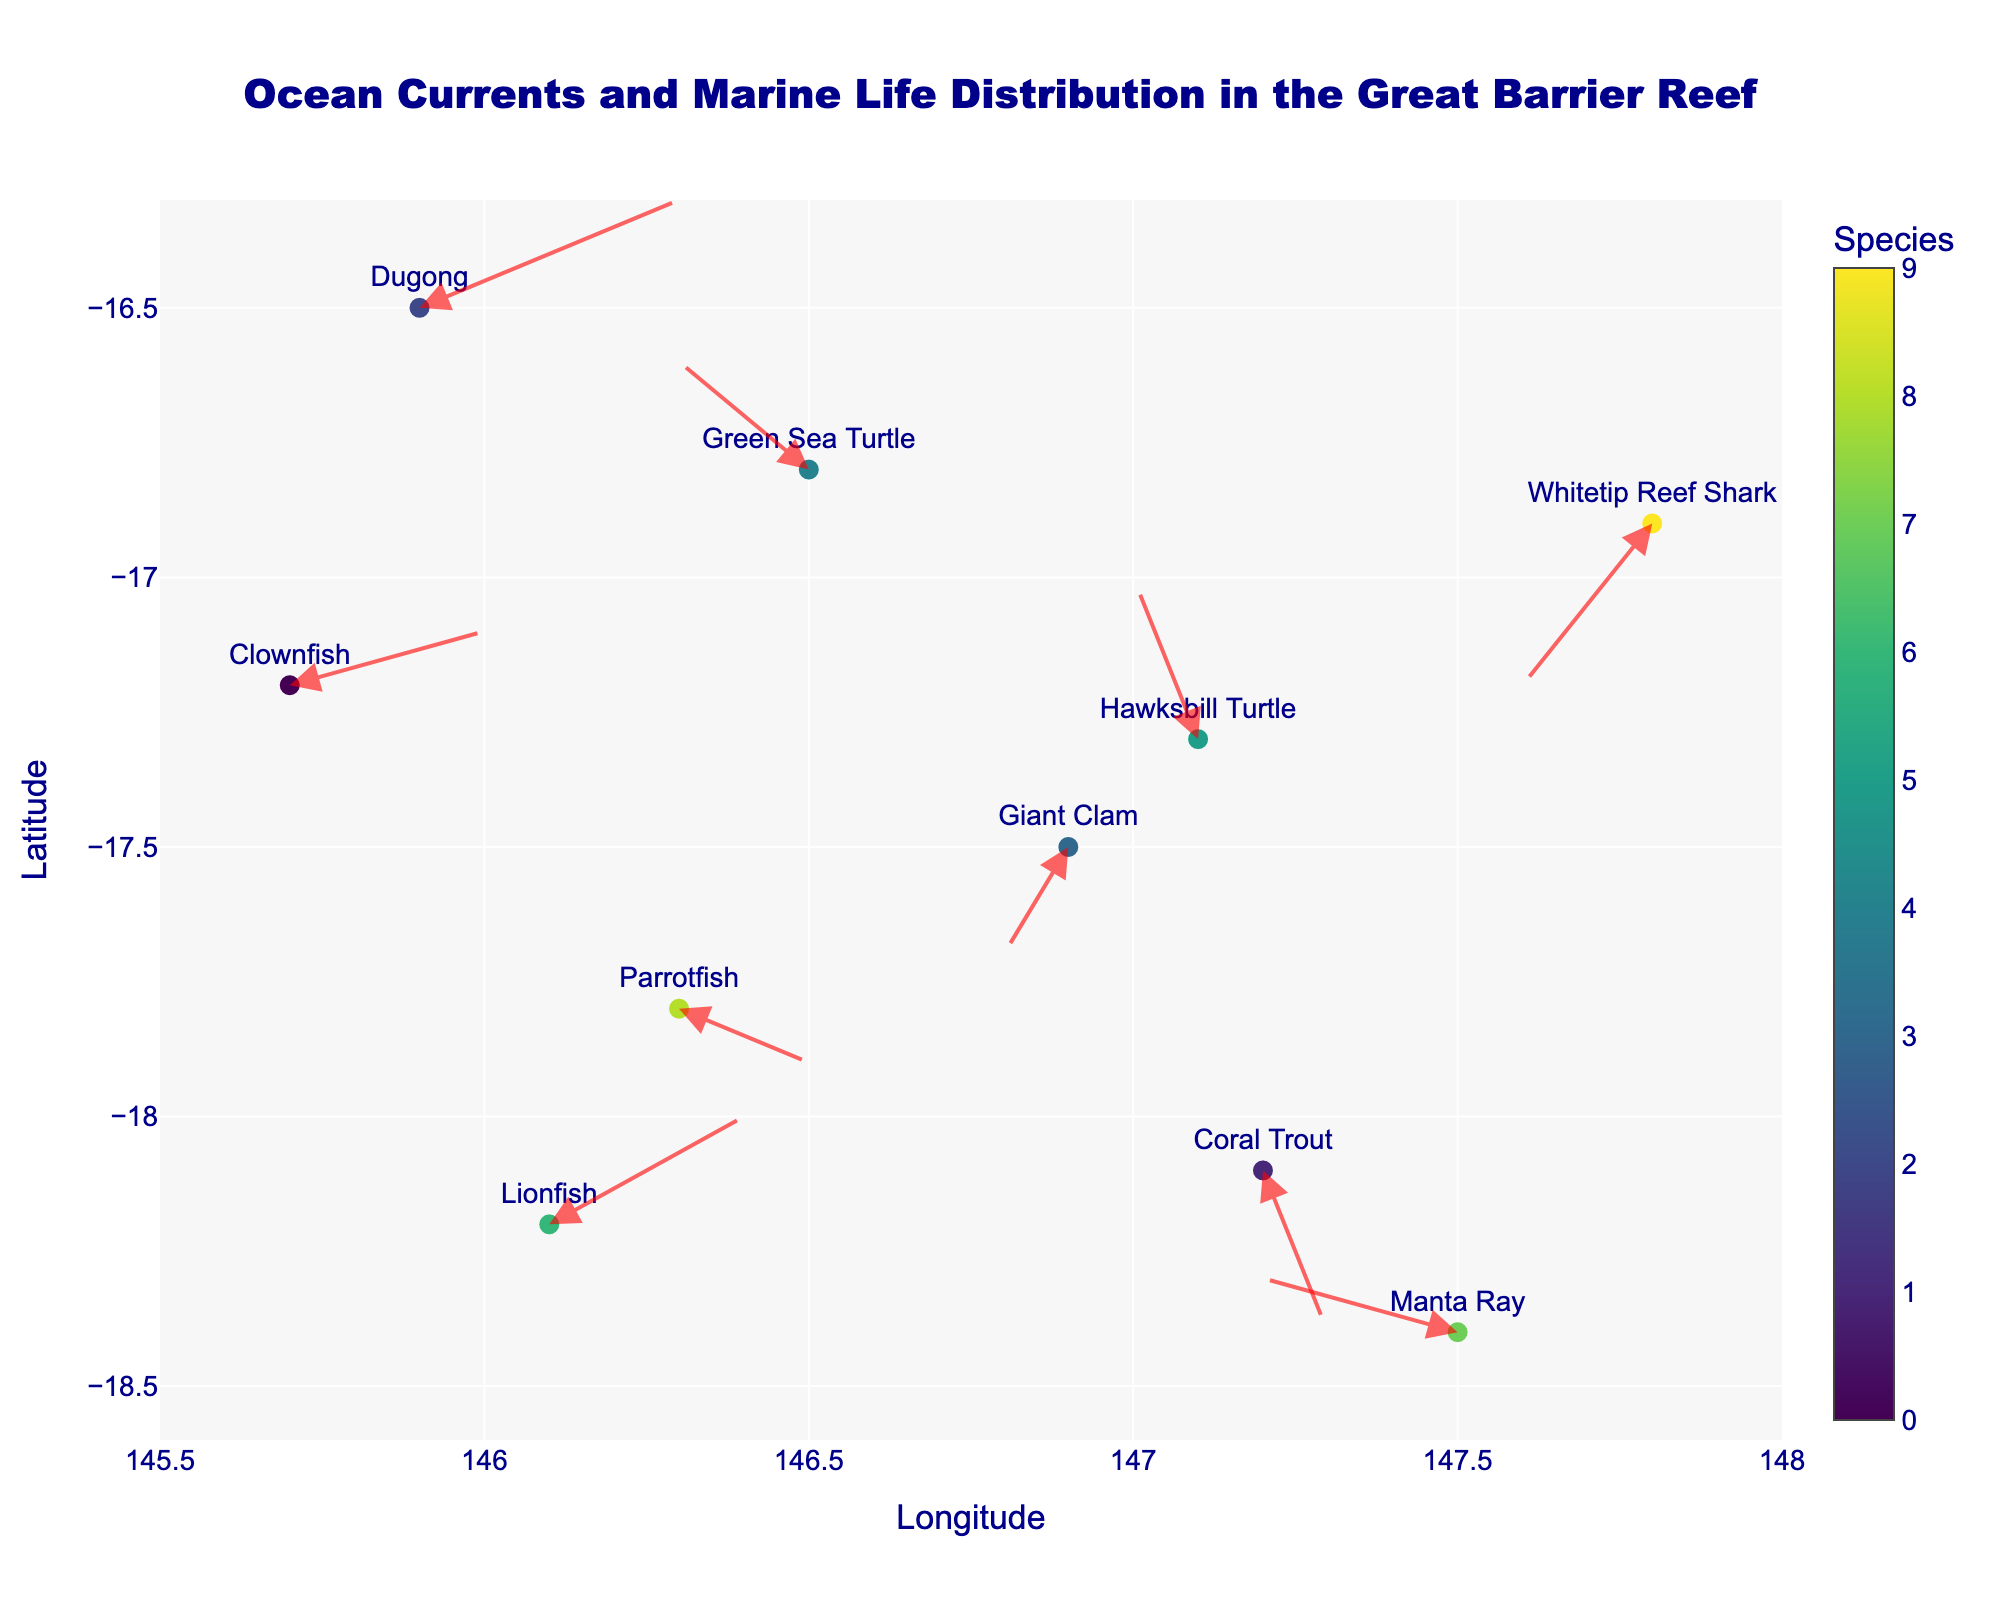What is the title of the plot? The title of the plot is usually placed at the top of the figure. In this case, the title indicates the main focus of the plot.
Answer: Ocean Currents and Marine Life Distribution in the Great Barrier Reef What information is displayed on the x-axis and y-axis? The x-axis and y-axis usually display the geographical coordinates in this context, representing longitude and latitude, respectively.
Answer: Longitude and Latitude How many species are represented in the plot? Each unique species corresponds to a different color or marker on the plot. By counting the unique species names, we can determine the total number of species.
Answer: 10 What direction is the ocean current affecting the Dugong? To find the direction of the ocean current affecting the Dugong, look at the arrow starting at the Dugong's point and note its direction.
Answer: Northeast Which species is experiencing the strongest current in any direction? The magnitude of the current can be determined by calculating the length of the arrow from its origin. The species with the longest arrow experiences the strongest current.
Answer: Dugong How is the Clownfish being affected by ocean currents? Identify the arrow starting at the Clownfish's location and note its direction and length to understand the current's impact.
Answer: Slightly northeast with moderate strength What is the general direction of ocean currents in the northern part of the plot? Observe the arrows in the northern section of the plot and identify a common direction they point towards.
Answer: Generally northeast Which two species have ocean currents pointing in almost opposite directions? Compare the directions of the arrows for different species and identify any pairs with arrows pointing in nearly opposite directions.
Answer: Clownfish and Hawksbill Turtle Which species is located at approximately (147.1, -17.3)? Find the geographic coordinates (longitude, latitude) on the plot and identify the species marked at this location.
Answer: Hawksbill Turtle Is the Manta Ray being pushed northward or southward by the ocean current? Check the direction of the arrow originating from the Manta Ray's position to determine its movement direction.
Answer: Northward 